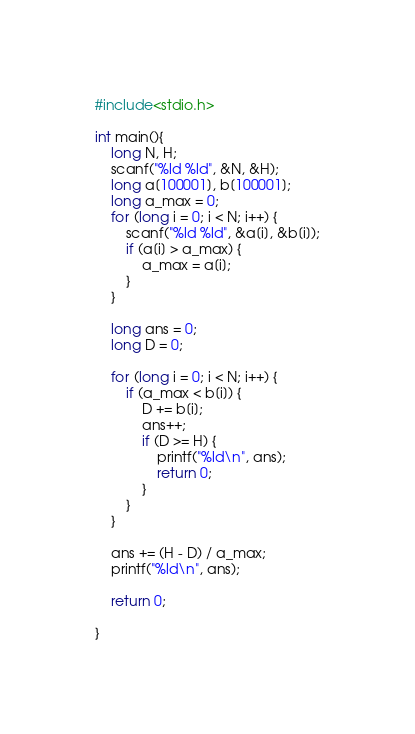<code> <loc_0><loc_0><loc_500><loc_500><_C_>#include<stdio.h>

int main(){
	long N, H;
	scanf("%ld %ld", &N, &H);
	long a[100001], b[100001];
	long a_max = 0;
	for (long i = 0; i < N; i++) {
		scanf("%ld %ld", &a[i], &b[i]);
		if (a[i] > a_max) {
			a_max = a[i];
		}
	}

	long ans = 0;
	long D = 0;

	for (long i = 0; i < N; i++) {
		if (a_max < b[i]) {
			D += b[i];
			ans++;
			if (D >= H) {
				printf("%ld\n", ans);
				return 0;
			}
		}
	}

	ans += (H - D) / a_max;
	printf("%ld\n", ans);

	return 0;

}</code> 